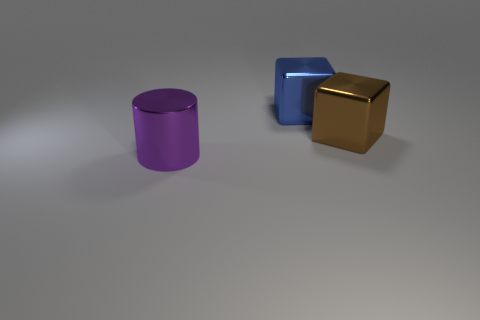Does the purple object that is on the left side of the brown object have the same size as the big blue cube?
Give a very brief answer. Yes. There is a large shiny object on the right side of the large blue shiny thing; what color is it?
Give a very brief answer. Brown. How many large metallic cylinders are there?
Make the answer very short. 1. There is a big purple object that is made of the same material as the big brown cube; what is its shape?
Make the answer very short. Cylinder. Are there an equal number of large metallic things behind the large purple object and large cylinders?
Provide a short and direct response. No. What number of cubes are right of the large purple metallic object?
Offer a very short reply. 2. There is a big cylinder that is made of the same material as the large blue thing; what color is it?
Offer a terse response. Purple. How many brown shiny blocks have the same size as the purple cylinder?
Provide a short and direct response. 1. Does the cube that is right of the large blue metal cube have the same material as the large purple thing?
Make the answer very short. Yes. Are there fewer blue shiny cubes that are behind the blue metal thing than large metal spheres?
Your answer should be very brief. No. 